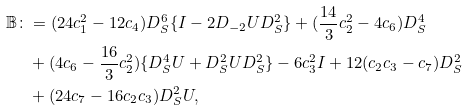<formula> <loc_0><loc_0><loc_500><loc_500>\mathbb { B } \colon & = ( 2 4 c _ { 1 } ^ { 2 } - 1 2 c _ { 4 } ) D _ { S } ^ { 6 } \{ I - 2 D _ { - 2 } U D _ { S } ^ { 2 } \} + ( \frac { 1 4 } { 3 } c _ { 2 } ^ { 2 } - 4 c _ { 6 } ) D _ { S } ^ { 4 } \\ & + ( 4 c _ { 6 } - \frac { 1 6 } { 3 } c _ { 2 } ^ { 2 } ) \{ D _ { S } ^ { 4 } U + D _ { S } ^ { 2 } U D _ { S } ^ { 2 } \} - 6 c _ { 3 } ^ { 2 } I + 1 2 ( c _ { 2 } c _ { 3 } - c _ { 7 } ) D _ { S } ^ { 2 } \\ & + ( 2 4 c _ { 7 } - 1 6 c _ { 2 } c _ { 3 } ) D _ { S } ^ { 2 } U ,</formula> 